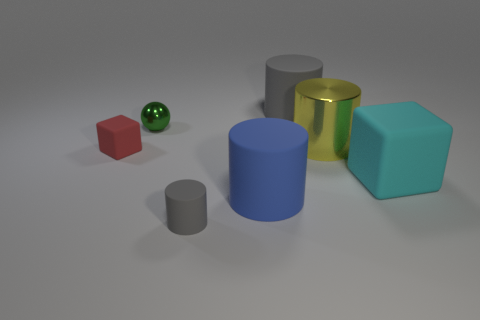Subtract 1 cylinders. How many cylinders are left? 3 Add 2 blue matte spheres. How many objects exist? 9 Subtract all brown cylinders. Subtract all gray blocks. How many cylinders are left? 4 Subtract all blocks. How many objects are left? 5 Subtract 0 brown cubes. How many objects are left? 7 Subtract all small cyan metal cubes. Subtract all big yellow things. How many objects are left? 6 Add 3 tiny gray rubber objects. How many tiny gray rubber objects are left? 4 Add 3 big metal cubes. How many big metal cubes exist? 3 